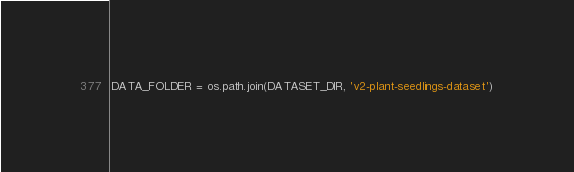Convert code to text. <code><loc_0><loc_0><loc_500><loc_500><_Python_>DATA_FOLDER = os.path.join(DATASET_DIR, 'v2-plant-seedlings-dataset')</code> 